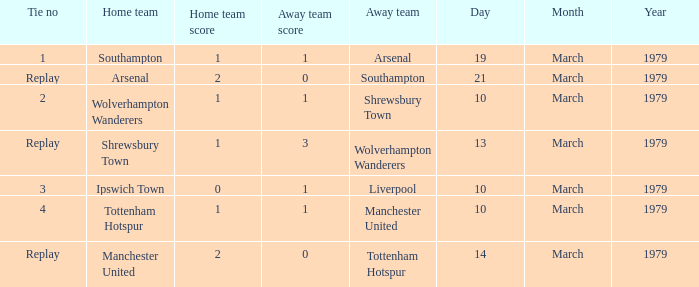What was the score of the tie that had Tottenham Hotspur as the home team? 1–1. 